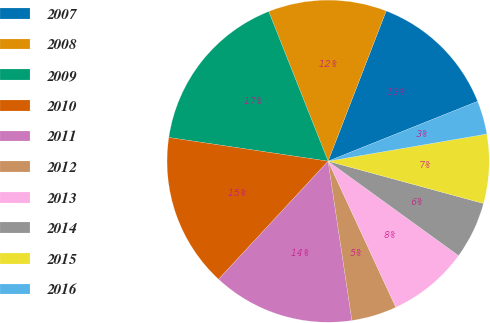Convert chart to OTSL. <chart><loc_0><loc_0><loc_500><loc_500><pie_chart><fcel>2007<fcel>2008<fcel>2009<fcel>2010<fcel>2011<fcel>2012<fcel>2013<fcel>2014<fcel>2015<fcel>2016<nl><fcel>13.07%<fcel>11.88%<fcel>16.64%<fcel>15.45%<fcel>14.26%<fcel>4.55%<fcel>8.12%<fcel>5.74%<fcel>6.93%<fcel>3.36%<nl></chart> 